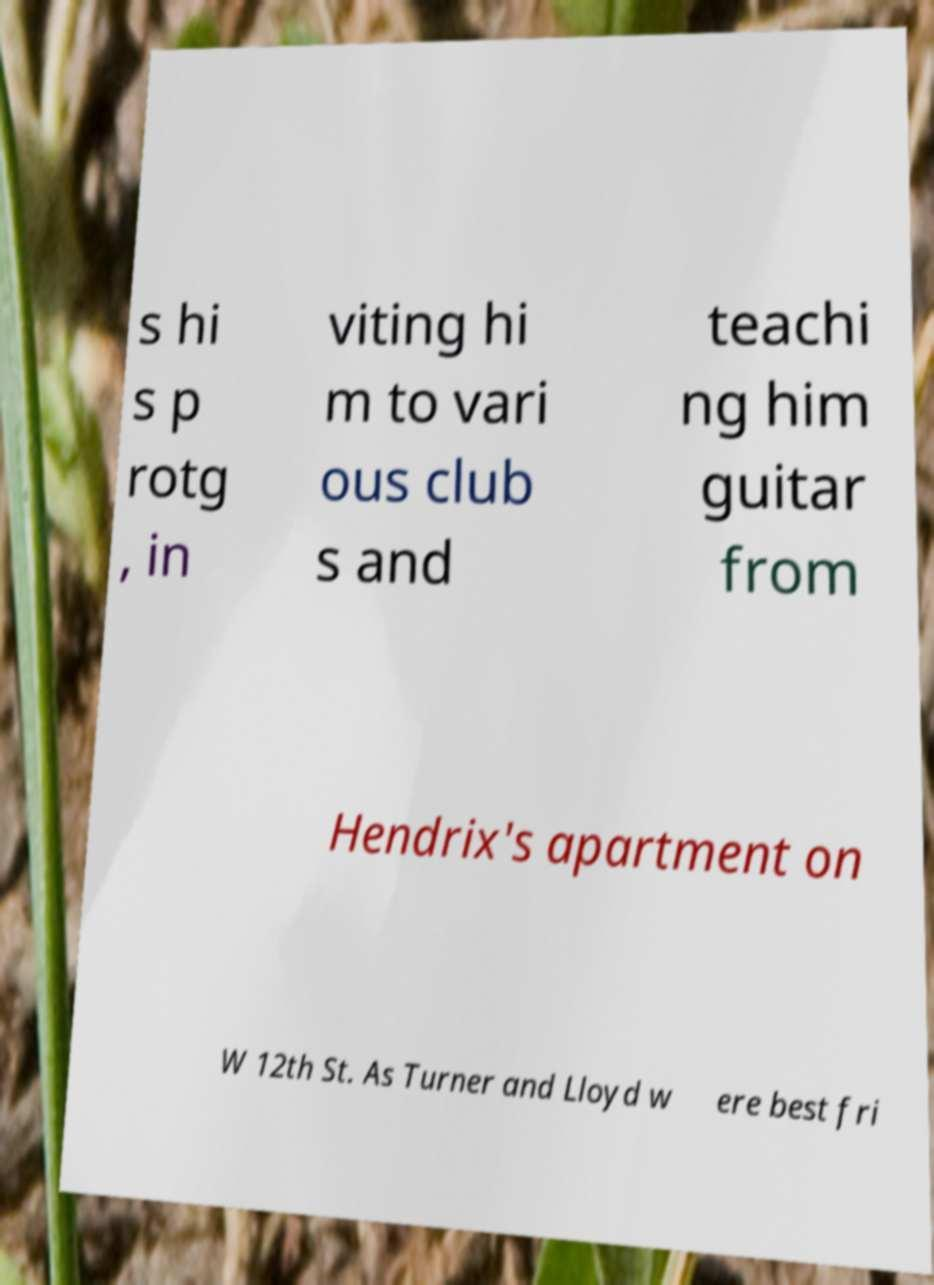Could you assist in decoding the text presented in this image and type it out clearly? s hi s p rotg , in viting hi m to vari ous club s and teachi ng him guitar from Hendrix's apartment on W 12th St. As Turner and Lloyd w ere best fri 